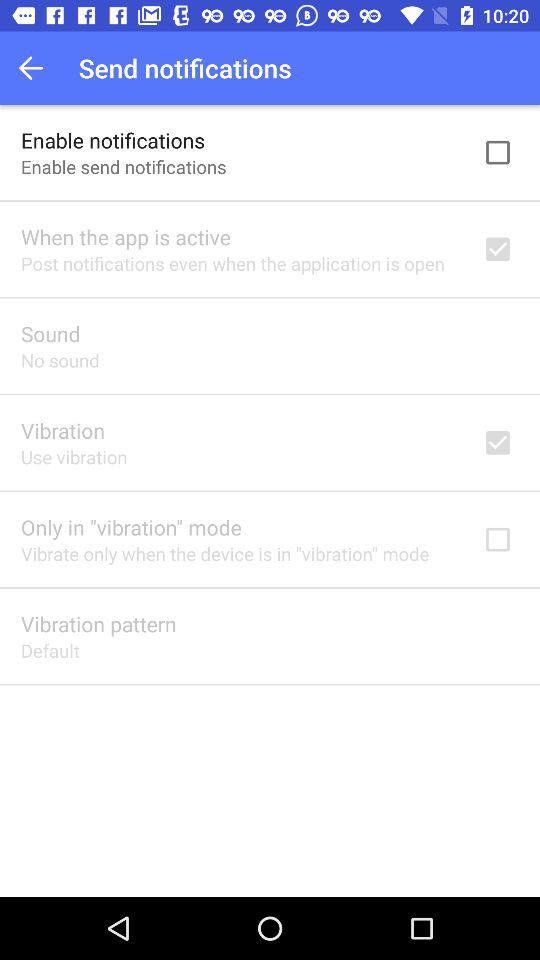What is the setting for the vibration pattern? The setting for the vibration pattern is "Default". 